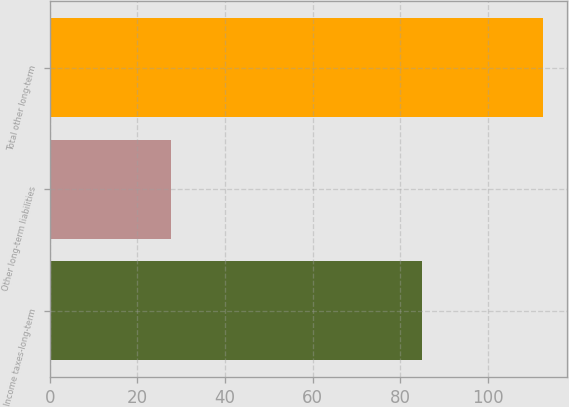<chart> <loc_0><loc_0><loc_500><loc_500><bar_chart><fcel>Income taxes-long-term<fcel>Other long-term liabilities<fcel>Total other long-term<nl><fcel>84.9<fcel>27.7<fcel>112.6<nl></chart> 